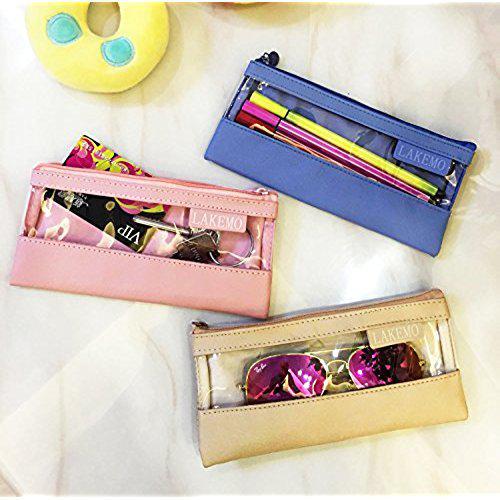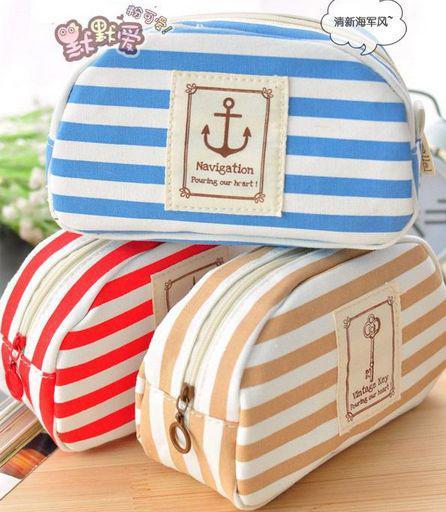The first image is the image on the left, the second image is the image on the right. Assess this claim about the two images: "The right image depicts at least three pencil cases.". Correct or not? Answer yes or no. Yes. 